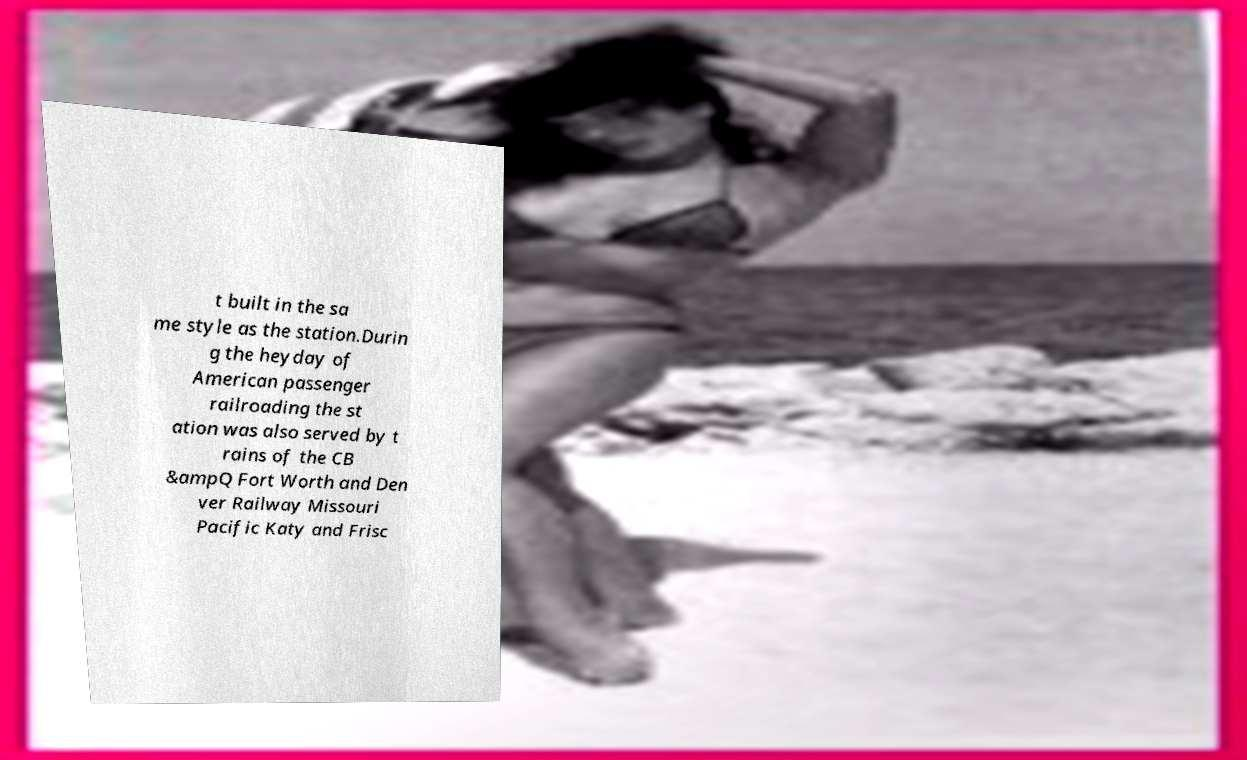There's text embedded in this image that I need extracted. Can you transcribe it verbatim? t built in the sa me style as the station.Durin g the heyday of American passenger railroading the st ation was also served by t rains of the CB &ampQ Fort Worth and Den ver Railway Missouri Pacific Katy and Frisc 